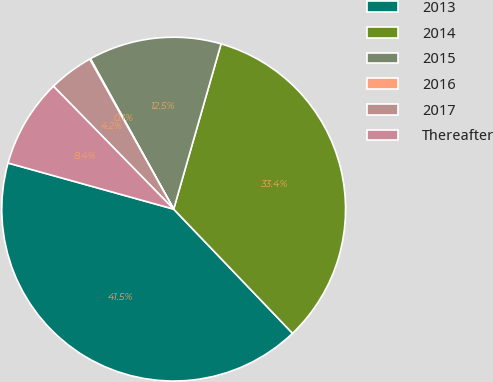<chart> <loc_0><loc_0><loc_500><loc_500><pie_chart><fcel>2013<fcel>2014<fcel>2015<fcel>2016<fcel>2017<fcel>Thereafter<nl><fcel>41.47%<fcel>33.4%<fcel>12.49%<fcel>0.07%<fcel>4.21%<fcel>8.35%<nl></chart> 